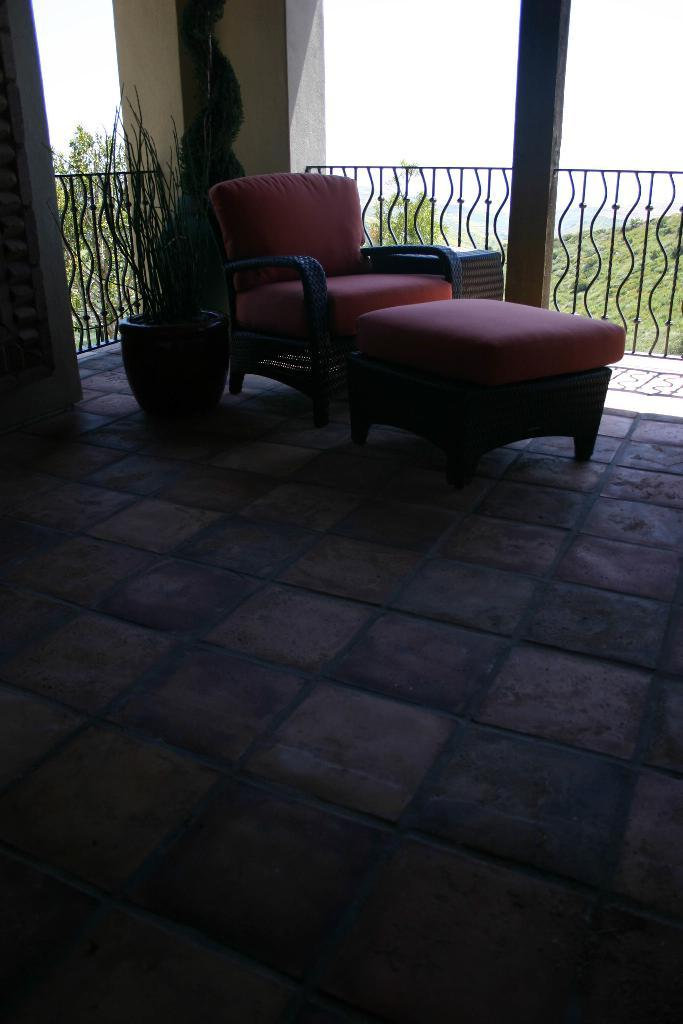What is the setting of the image? The image is inside a room. What furniture can be seen in the background of the image? There is a couch on the right side in the background. What type of barrier is visible in the background? There is a metal fence visible in the background. What type of natural elements can be seen in the background? Trees are present in the background. What is visible at the top of the image? The sky is visible at the top of the image. How many children are playing on the grass in the image? There is no grass or children present in the image. 